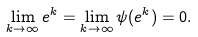<formula> <loc_0><loc_0><loc_500><loc_500>\lim _ { k \to \infty } e ^ { k } = \lim _ { k \to \infty } \psi ( e ^ { k } ) = 0 .</formula> 